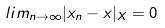<formula> <loc_0><loc_0><loc_500><loc_500>l i m _ { n \rightarrow \infty } | x _ { n } - x | _ { X } = 0</formula> 